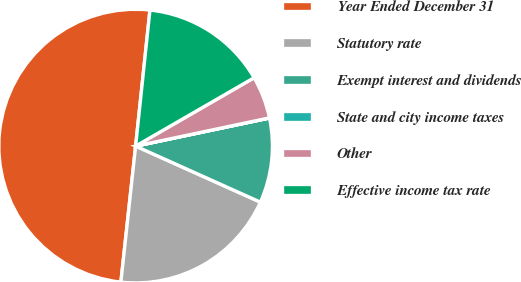Convert chart. <chart><loc_0><loc_0><loc_500><loc_500><pie_chart><fcel>Year Ended December 31<fcel>Statutory rate<fcel>Exempt interest and dividends<fcel>State and city income taxes<fcel>Other<fcel>Effective income tax rate<nl><fcel>49.95%<fcel>20.0%<fcel>10.01%<fcel>0.02%<fcel>5.02%<fcel>15.0%<nl></chart> 